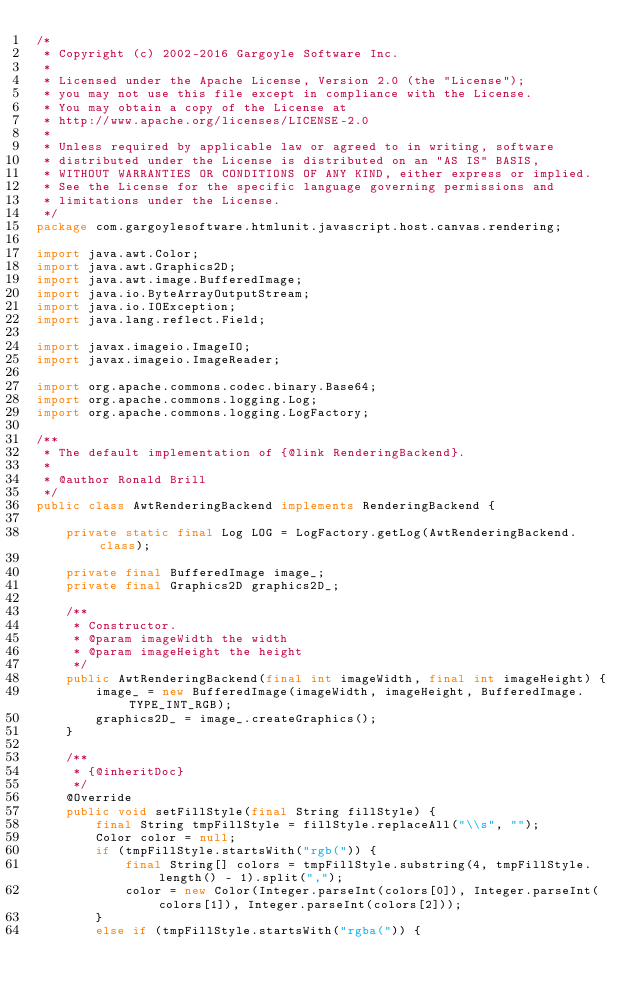<code> <loc_0><loc_0><loc_500><loc_500><_Java_>/*
 * Copyright (c) 2002-2016 Gargoyle Software Inc.
 *
 * Licensed under the Apache License, Version 2.0 (the "License");
 * you may not use this file except in compliance with the License.
 * You may obtain a copy of the License at
 * http://www.apache.org/licenses/LICENSE-2.0
 *
 * Unless required by applicable law or agreed to in writing, software
 * distributed under the License is distributed on an "AS IS" BASIS,
 * WITHOUT WARRANTIES OR CONDITIONS OF ANY KIND, either express or implied.
 * See the License for the specific language governing permissions and
 * limitations under the License.
 */
package com.gargoylesoftware.htmlunit.javascript.host.canvas.rendering;

import java.awt.Color;
import java.awt.Graphics2D;
import java.awt.image.BufferedImage;
import java.io.ByteArrayOutputStream;
import java.io.IOException;
import java.lang.reflect.Field;

import javax.imageio.ImageIO;
import javax.imageio.ImageReader;

import org.apache.commons.codec.binary.Base64;
import org.apache.commons.logging.Log;
import org.apache.commons.logging.LogFactory;

/**
 * The default implementation of {@link RenderingBackend}.
 *
 * @author Ronald Brill
 */
public class AwtRenderingBackend implements RenderingBackend {

    private static final Log LOG = LogFactory.getLog(AwtRenderingBackend.class);

    private final BufferedImage image_;
    private final Graphics2D graphics2D_;

    /**
     * Constructor.
     * @param imageWidth the width
     * @param imageHeight the height
     */
    public AwtRenderingBackend(final int imageWidth, final int imageHeight) {
        image_ = new BufferedImage(imageWidth, imageHeight, BufferedImage.TYPE_INT_RGB);
        graphics2D_ = image_.createGraphics();
    }

    /**
     * {@inheritDoc}
     */
    @Override
    public void setFillStyle(final String fillStyle) {
        final String tmpFillStyle = fillStyle.replaceAll("\\s", "");
        Color color = null;
        if (tmpFillStyle.startsWith("rgb(")) {
            final String[] colors = tmpFillStyle.substring(4, tmpFillStyle.length() - 1).split(",");
            color = new Color(Integer.parseInt(colors[0]), Integer.parseInt(colors[1]), Integer.parseInt(colors[2]));
        }
        else if (tmpFillStyle.startsWith("rgba(")) {</code> 